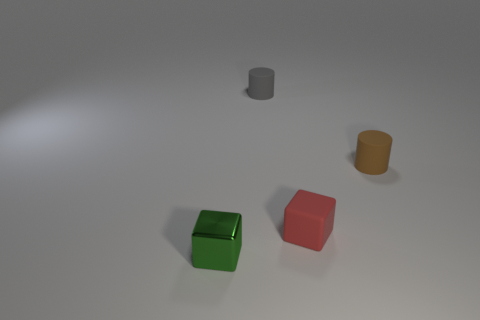Is the number of red rubber objects that are to the right of the gray cylinder the same as the number of tiny brown rubber cylinders?
Your response must be concise. Yes. How many things are either tiny red blocks or brown things?
Your answer should be compact. 2. What is the shape of the red thing that is made of the same material as the tiny brown cylinder?
Give a very brief answer. Cube. How many large objects are either brown rubber cylinders or green things?
Offer a terse response. 0. What number of other objects are there of the same color as the rubber cube?
Your answer should be compact. 0. There is a brown cylinder on the right side of the matte cube; does it have the same size as the matte cylinder left of the small red cube?
Provide a succinct answer. Yes. Are the small brown thing and the small block behind the tiny metallic block made of the same material?
Keep it short and to the point. Yes. Is the number of metallic blocks behind the tiny red matte cube greater than the number of red things that are in front of the green shiny object?
Give a very brief answer. No. There is a tiny matte object that is on the right side of the small cube that is to the right of the small green block; what color is it?
Give a very brief answer. Brown. What number of spheres are either cyan metallic objects or matte objects?
Provide a succinct answer. 0. 